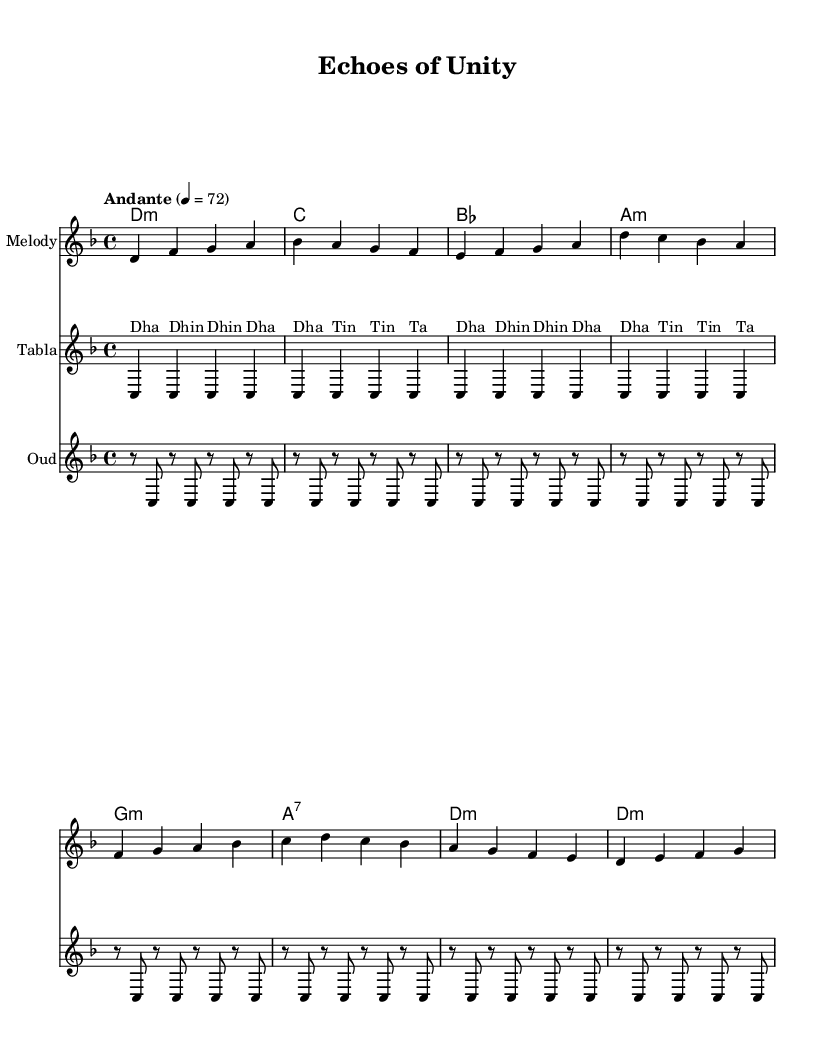What is the key signature of this music? The key signature is D minor, which has one flat (B flat) and indicates that the music is mostly based around the D minor scale.
Answer: D minor What is the time signature of this music? The time signature is 4/4, which means there are four beats in each measure and the quarter note gets one beat.
Answer: 4/4 What is the tempo marking of this music? The tempo marking is "Andante," which indicates a moderate walking pace, generally around 76 to 108 beats per minute.
Answer: Andante How many measures are in the main theme A? By counting the measures in the provided notation for main theme A, we see there are 4 distinct measures.
Answer: 4 What instruments are featured in this piece? The instruments featured in this piece are the Melody, Tabla, and Oud, as indicated by their respective staff titles.
Answer: Melody, Tabla, Oud Which chord follows the D minor chord in harmony A? The D minor chord is followed by a C major chord, which can be noticed in the chord progression for harmony A.
Answer: C How many repetitions does the Tabla part have? The Tabla part contains 2 repetitions of the rhythmic pattern, as shown by the “\repeat unfold 2” instruction in the code.
Answer: 2 